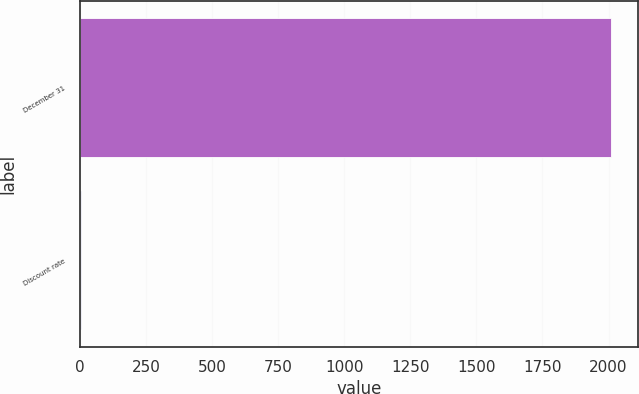<chart> <loc_0><loc_0><loc_500><loc_500><bar_chart><fcel>December 31<fcel>Discount rate<nl><fcel>2010<fcel>5.25<nl></chart> 